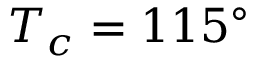<formula> <loc_0><loc_0><loc_500><loc_500>T _ { c } = 1 1 5 ^ { \circ }</formula> 